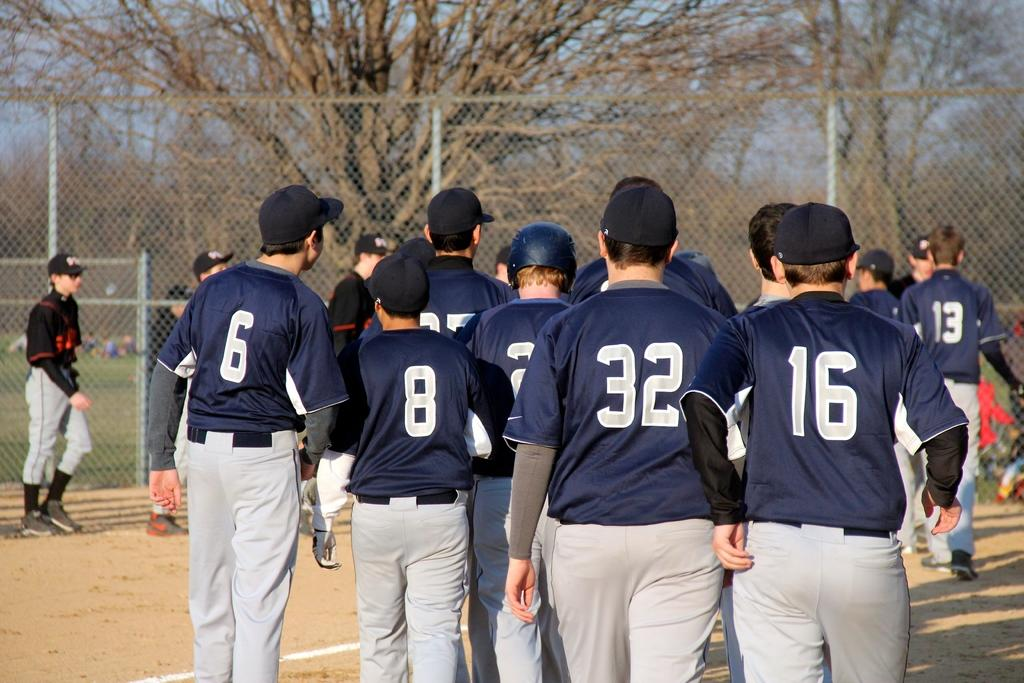<image>
Give a short and clear explanation of the subsequent image. a group of players standing and one wears 16 